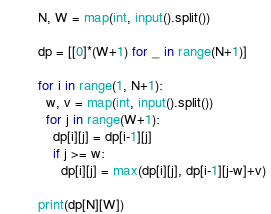Convert code to text. <code><loc_0><loc_0><loc_500><loc_500><_Python_>N, W = map(int, input().split())

dp = [[0]*(W+1) for _ in range(N+1)]

for i in range(1, N+1):
  w, v = map(int, input().split())
  for j in range(W+1):
    dp[i][j] = dp[i-1][j]
    if j >= w:
      dp[i][j] = max(dp[i][j], dp[i-1][j-w]+v)

print(dp[N][W])</code> 